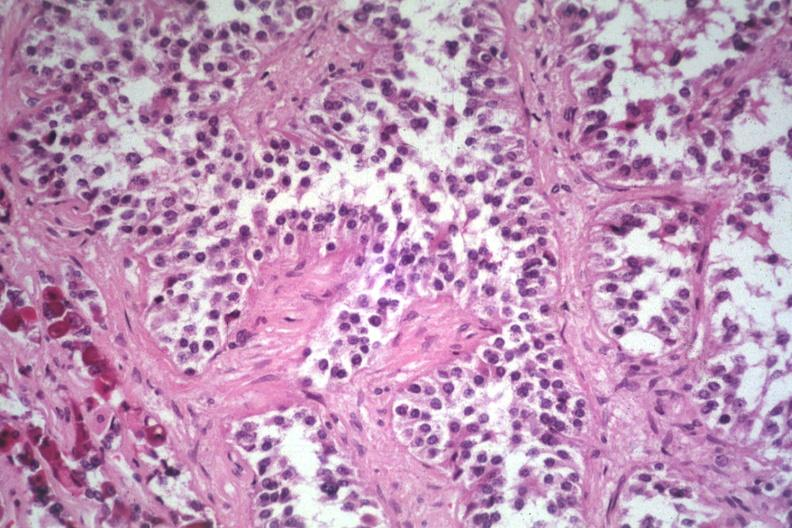s endocrine present?
Answer the question using a single word or phrase. Yes 